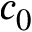Convert formula to latex. <formula><loc_0><loc_0><loc_500><loc_500>c _ { 0 }</formula> 